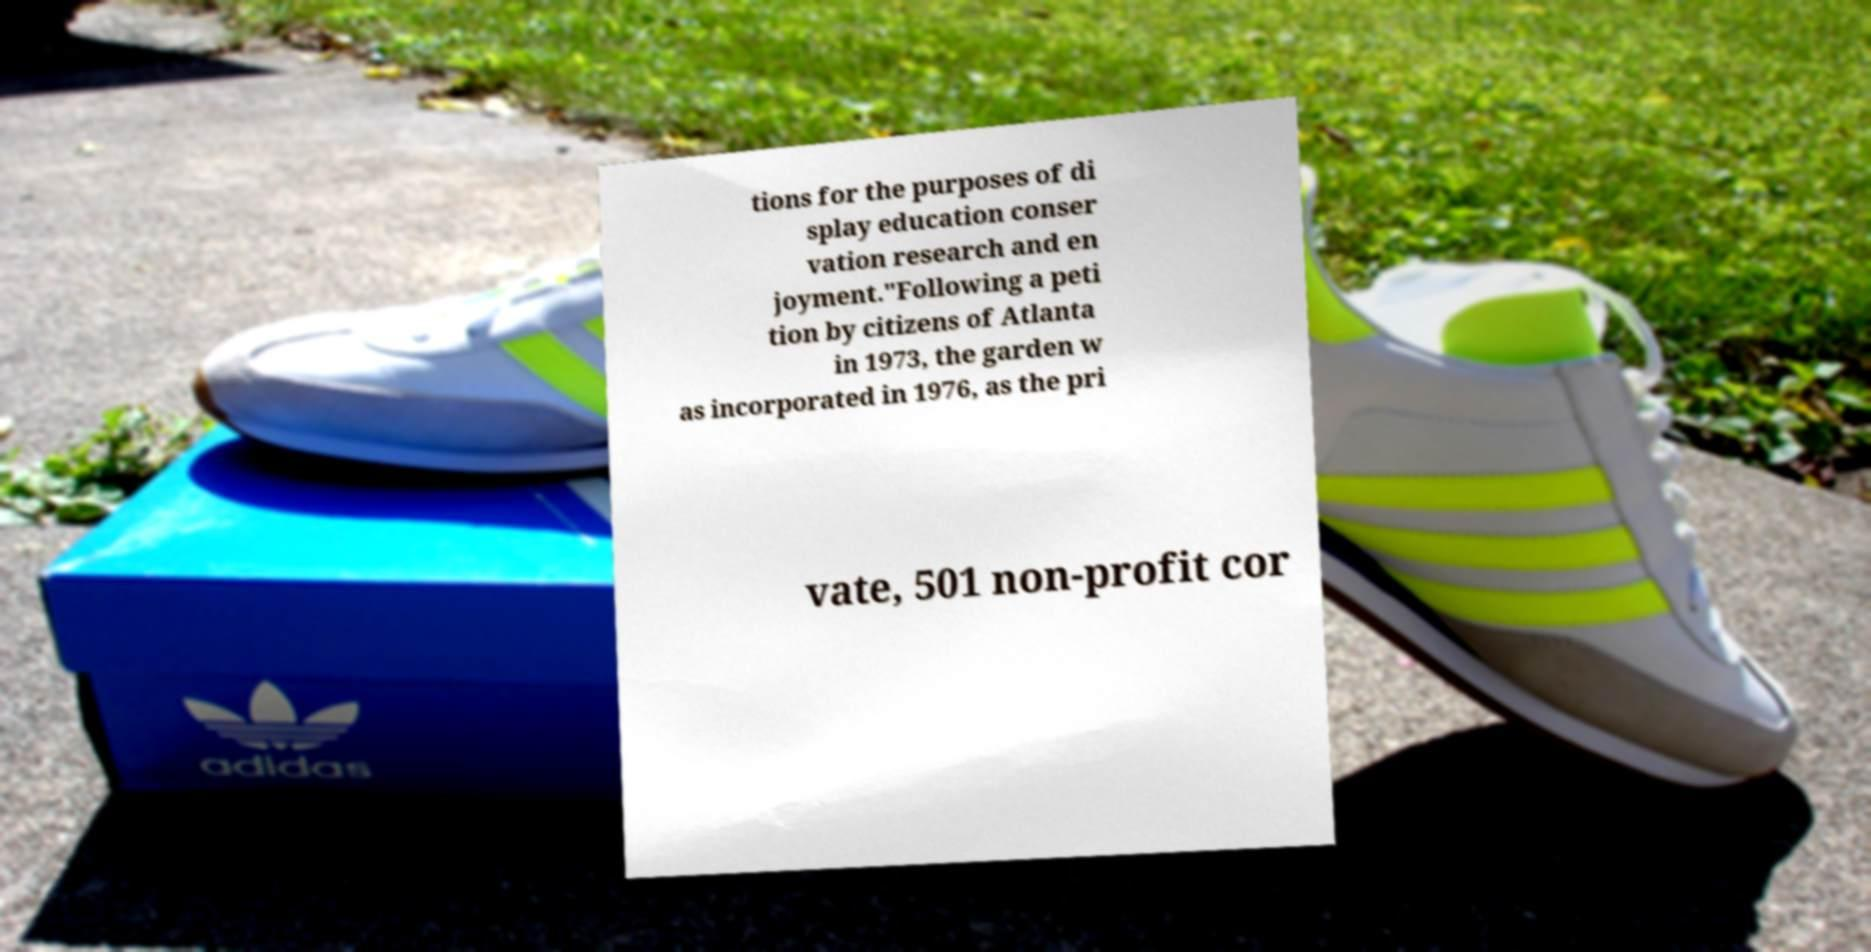What messages or text are displayed in this image? I need them in a readable, typed format. tions for the purposes of di splay education conser vation research and en joyment."Following a peti tion by citizens of Atlanta in 1973, the garden w as incorporated in 1976, as the pri vate, 501 non-profit cor 